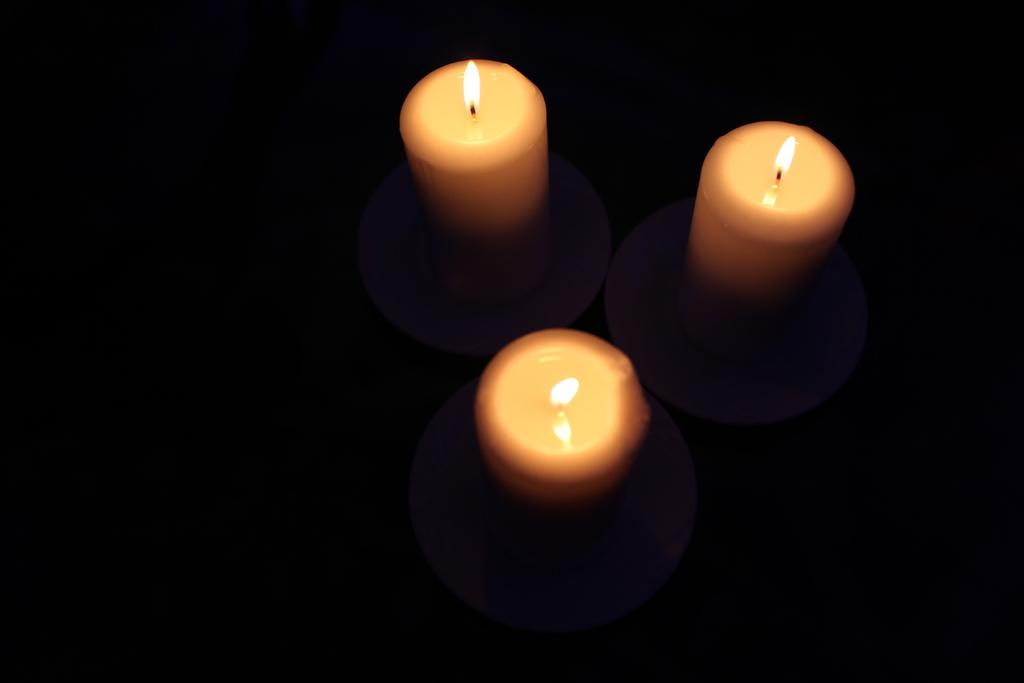How many candles are present in the image? There are three candles in the image. What is the state of the candles in the image? The candles are on fire. What type of stove can be seen in the image? There is no stove present in the image; it only features three candles on fire. How many friends are visible in the image? There are no friends visible in the image; it only features three candles on fire. 